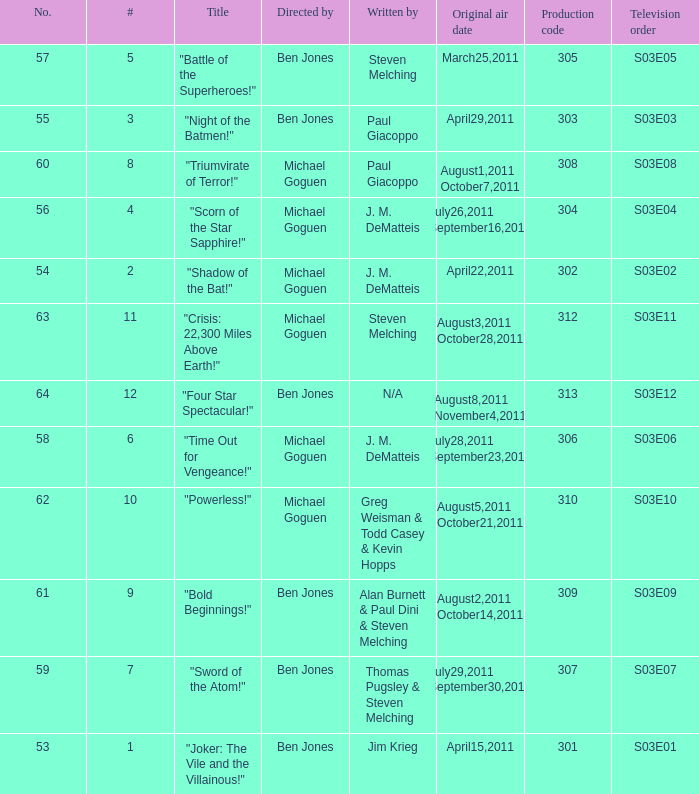What is the original air date of the episode directed by ben jones and written by steven melching?  March25,2011. 